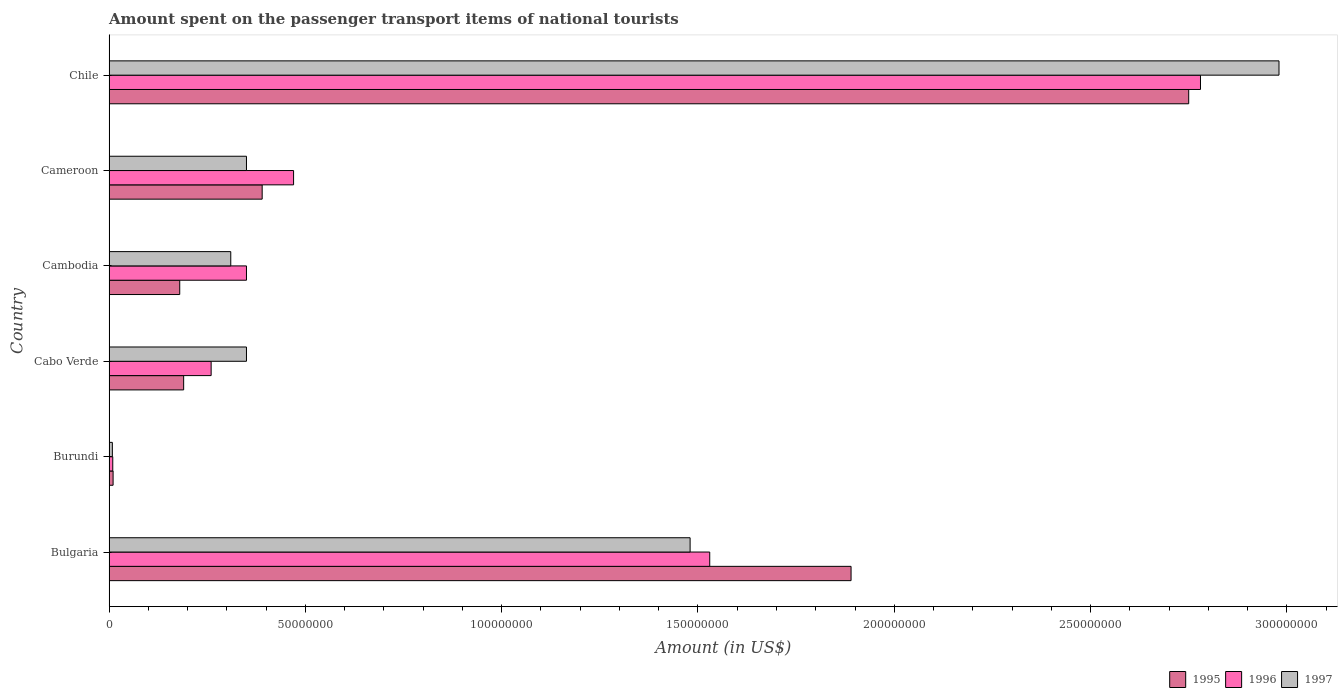How many different coloured bars are there?
Your response must be concise. 3. Are the number of bars on each tick of the Y-axis equal?
Offer a terse response. Yes. How many bars are there on the 4th tick from the bottom?
Make the answer very short. 3. What is the label of the 2nd group of bars from the top?
Your answer should be compact. Cameroon. In how many cases, is the number of bars for a given country not equal to the number of legend labels?
Offer a terse response. 0. What is the amount spent on the passenger transport items of national tourists in 1995 in Burundi?
Your response must be concise. 1.02e+06. Across all countries, what is the maximum amount spent on the passenger transport items of national tourists in 1996?
Make the answer very short. 2.78e+08. Across all countries, what is the minimum amount spent on the passenger transport items of national tourists in 1996?
Your answer should be very brief. 9.41e+05. In which country was the amount spent on the passenger transport items of national tourists in 1997 maximum?
Provide a succinct answer. Chile. In which country was the amount spent on the passenger transport items of national tourists in 1996 minimum?
Your response must be concise. Burundi. What is the total amount spent on the passenger transport items of national tourists in 1995 in the graph?
Make the answer very short. 5.41e+08. What is the difference between the amount spent on the passenger transport items of national tourists in 1996 in Bulgaria and that in Cambodia?
Your response must be concise. 1.18e+08. What is the difference between the amount spent on the passenger transport items of national tourists in 1997 in Chile and the amount spent on the passenger transport items of national tourists in 1996 in Cambodia?
Offer a very short reply. 2.63e+08. What is the average amount spent on the passenger transport items of national tourists in 1996 per country?
Ensure brevity in your answer.  9.00e+07. What is the difference between the amount spent on the passenger transport items of national tourists in 1995 and amount spent on the passenger transport items of national tourists in 1996 in Chile?
Offer a very short reply. -3.00e+06. What is the ratio of the amount spent on the passenger transport items of national tourists in 1997 in Burundi to that in Cameroon?
Provide a succinct answer. 0.02. What is the difference between the highest and the second highest amount spent on the passenger transport items of national tourists in 1997?
Your answer should be very brief. 1.50e+08. What is the difference between the highest and the lowest amount spent on the passenger transport items of national tourists in 1995?
Offer a very short reply. 2.74e+08. Is the sum of the amount spent on the passenger transport items of national tourists in 1996 in Bulgaria and Burundi greater than the maximum amount spent on the passenger transport items of national tourists in 1995 across all countries?
Your answer should be compact. No. What does the 1st bar from the top in Burundi represents?
Your answer should be compact. 1997. What does the 1st bar from the bottom in Cameroon represents?
Make the answer very short. 1995. What is the difference between two consecutive major ticks on the X-axis?
Provide a short and direct response. 5.00e+07. Does the graph contain any zero values?
Make the answer very short. No. How many legend labels are there?
Give a very brief answer. 3. What is the title of the graph?
Your response must be concise. Amount spent on the passenger transport items of national tourists. Does "1979" appear as one of the legend labels in the graph?
Ensure brevity in your answer.  No. What is the label or title of the X-axis?
Offer a terse response. Amount (in US$). What is the label or title of the Y-axis?
Offer a terse response. Country. What is the Amount (in US$) of 1995 in Bulgaria?
Your answer should be very brief. 1.89e+08. What is the Amount (in US$) in 1996 in Bulgaria?
Your answer should be compact. 1.53e+08. What is the Amount (in US$) in 1997 in Bulgaria?
Your response must be concise. 1.48e+08. What is the Amount (in US$) in 1995 in Burundi?
Make the answer very short. 1.02e+06. What is the Amount (in US$) of 1996 in Burundi?
Ensure brevity in your answer.  9.41e+05. What is the Amount (in US$) of 1997 in Burundi?
Give a very brief answer. 8.40e+05. What is the Amount (in US$) in 1995 in Cabo Verde?
Make the answer very short. 1.90e+07. What is the Amount (in US$) of 1996 in Cabo Verde?
Your answer should be compact. 2.60e+07. What is the Amount (in US$) in 1997 in Cabo Verde?
Provide a short and direct response. 3.50e+07. What is the Amount (in US$) in 1995 in Cambodia?
Offer a terse response. 1.80e+07. What is the Amount (in US$) in 1996 in Cambodia?
Give a very brief answer. 3.50e+07. What is the Amount (in US$) of 1997 in Cambodia?
Give a very brief answer. 3.10e+07. What is the Amount (in US$) in 1995 in Cameroon?
Provide a short and direct response. 3.90e+07. What is the Amount (in US$) of 1996 in Cameroon?
Make the answer very short. 4.70e+07. What is the Amount (in US$) of 1997 in Cameroon?
Keep it short and to the point. 3.50e+07. What is the Amount (in US$) in 1995 in Chile?
Provide a succinct answer. 2.75e+08. What is the Amount (in US$) in 1996 in Chile?
Provide a short and direct response. 2.78e+08. What is the Amount (in US$) of 1997 in Chile?
Your response must be concise. 2.98e+08. Across all countries, what is the maximum Amount (in US$) of 1995?
Your answer should be very brief. 2.75e+08. Across all countries, what is the maximum Amount (in US$) in 1996?
Your response must be concise. 2.78e+08. Across all countries, what is the maximum Amount (in US$) in 1997?
Keep it short and to the point. 2.98e+08. Across all countries, what is the minimum Amount (in US$) in 1995?
Your answer should be very brief. 1.02e+06. Across all countries, what is the minimum Amount (in US$) in 1996?
Keep it short and to the point. 9.41e+05. Across all countries, what is the minimum Amount (in US$) of 1997?
Your response must be concise. 8.40e+05. What is the total Amount (in US$) in 1995 in the graph?
Make the answer very short. 5.41e+08. What is the total Amount (in US$) of 1996 in the graph?
Your answer should be very brief. 5.40e+08. What is the total Amount (in US$) in 1997 in the graph?
Provide a succinct answer. 5.48e+08. What is the difference between the Amount (in US$) of 1995 in Bulgaria and that in Burundi?
Offer a terse response. 1.88e+08. What is the difference between the Amount (in US$) in 1996 in Bulgaria and that in Burundi?
Keep it short and to the point. 1.52e+08. What is the difference between the Amount (in US$) of 1997 in Bulgaria and that in Burundi?
Your answer should be compact. 1.47e+08. What is the difference between the Amount (in US$) of 1995 in Bulgaria and that in Cabo Verde?
Your answer should be very brief. 1.70e+08. What is the difference between the Amount (in US$) in 1996 in Bulgaria and that in Cabo Verde?
Provide a short and direct response. 1.27e+08. What is the difference between the Amount (in US$) in 1997 in Bulgaria and that in Cabo Verde?
Your answer should be compact. 1.13e+08. What is the difference between the Amount (in US$) of 1995 in Bulgaria and that in Cambodia?
Your answer should be compact. 1.71e+08. What is the difference between the Amount (in US$) in 1996 in Bulgaria and that in Cambodia?
Provide a short and direct response. 1.18e+08. What is the difference between the Amount (in US$) in 1997 in Bulgaria and that in Cambodia?
Make the answer very short. 1.17e+08. What is the difference between the Amount (in US$) of 1995 in Bulgaria and that in Cameroon?
Offer a terse response. 1.50e+08. What is the difference between the Amount (in US$) of 1996 in Bulgaria and that in Cameroon?
Keep it short and to the point. 1.06e+08. What is the difference between the Amount (in US$) of 1997 in Bulgaria and that in Cameroon?
Your answer should be compact. 1.13e+08. What is the difference between the Amount (in US$) in 1995 in Bulgaria and that in Chile?
Provide a short and direct response. -8.60e+07. What is the difference between the Amount (in US$) of 1996 in Bulgaria and that in Chile?
Ensure brevity in your answer.  -1.25e+08. What is the difference between the Amount (in US$) of 1997 in Bulgaria and that in Chile?
Your answer should be compact. -1.50e+08. What is the difference between the Amount (in US$) in 1995 in Burundi and that in Cabo Verde?
Your response must be concise. -1.80e+07. What is the difference between the Amount (in US$) in 1996 in Burundi and that in Cabo Verde?
Your answer should be compact. -2.51e+07. What is the difference between the Amount (in US$) of 1997 in Burundi and that in Cabo Verde?
Make the answer very short. -3.42e+07. What is the difference between the Amount (in US$) in 1995 in Burundi and that in Cambodia?
Provide a short and direct response. -1.70e+07. What is the difference between the Amount (in US$) in 1996 in Burundi and that in Cambodia?
Make the answer very short. -3.41e+07. What is the difference between the Amount (in US$) in 1997 in Burundi and that in Cambodia?
Give a very brief answer. -3.02e+07. What is the difference between the Amount (in US$) of 1995 in Burundi and that in Cameroon?
Provide a short and direct response. -3.80e+07. What is the difference between the Amount (in US$) of 1996 in Burundi and that in Cameroon?
Provide a short and direct response. -4.61e+07. What is the difference between the Amount (in US$) in 1997 in Burundi and that in Cameroon?
Make the answer very short. -3.42e+07. What is the difference between the Amount (in US$) of 1995 in Burundi and that in Chile?
Keep it short and to the point. -2.74e+08. What is the difference between the Amount (in US$) of 1996 in Burundi and that in Chile?
Offer a very short reply. -2.77e+08. What is the difference between the Amount (in US$) in 1997 in Burundi and that in Chile?
Provide a succinct answer. -2.97e+08. What is the difference between the Amount (in US$) of 1995 in Cabo Verde and that in Cambodia?
Ensure brevity in your answer.  1.00e+06. What is the difference between the Amount (in US$) of 1996 in Cabo Verde and that in Cambodia?
Provide a short and direct response. -9.00e+06. What is the difference between the Amount (in US$) in 1997 in Cabo Verde and that in Cambodia?
Your response must be concise. 4.00e+06. What is the difference between the Amount (in US$) of 1995 in Cabo Verde and that in Cameroon?
Offer a very short reply. -2.00e+07. What is the difference between the Amount (in US$) of 1996 in Cabo Verde and that in Cameroon?
Ensure brevity in your answer.  -2.10e+07. What is the difference between the Amount (in US$) in 1995 in Cabo Verde and that in Chile?
Your answer should be compact. -2.56e+08. What is the difference between the Amount (in US$) in 1996 in Cabo Verde and that in Chile?
Offer a terse response. -2.52e+08. What is the difference between the Amount (in US$) in 1997 in Cabo Verde and that in Chile?
Your answer should be very brief. -2.63e+08. What is the difference between the Amount (in US$) of 1995 in Cambodia and that in Cameroon?
Make the answer very short. -2.10e+07. What is the difference between the Amount (in US$) in 1996 in Cambodia and that in Cameroon?
Ensure brevity in your answer.  -1.20e+07. What is the difference between the Amount (in US$) in 1997 in Cambodia and that in Cameroon?
Give a very brief answer. -4.00e+06. What is the difference between the Amount (in US$) in 1995 in Cambodia and that in Chile?
Give a very brief answer. -2.57e+08. What is the difference between the Amount (in US$) in 1996 in Cambodia and that in Chile?
Your answer should be very brief. -2.43e+08. What is the difference between the Amount (in US$) in 1997 in Cambodia and that in Chile?
Offer a very short reply. -2.67e+08. What is the difference between the Amount (in US$) of 1995 in Cameroon and that in Chile?
Offer a very short reply. -2.36e+08. What is the difference between the Amount (in US$) of 1996 in Cameroon and that in Chile?
Provide a succinct answer. -2.31e+08. What is the difference between the Amount (in US$) of 1997 in Cameroon and that in Chile?
Offer a terse response. -2.63e+08. What is the difference between the Amount (in US$) of 1995 in Bulgaria and the Amount (in US$) of 1996 in Burundi?
Your answer should be compact. 1.88e+08. What is the difference between the Amount (in US$) of 1995 in Bulgaria and the Amount (in US$) of 1997 in Burundi?
Offer a very short reply. 1.88e+08. What is the difference between the Amount (in US$) in 1996 in Bulgaria and the Amount (in US$) in 1997 in Burundi?
Offer a very short reply. 1.52e+08. What is the difference between the Amount (in US$) in 1995 in Bulgaria and the Amount (in US$) in 1996 in Cabo Verde?
Your answer should be very brief. 1.63e+08. What is the difference between the Amount (in US$) in 1995 in Bulgaria and the Amount (in US$) in 1997 in Cabo Verde?
Give a very brief answer. 1.54e+08. What is the difference between the Amount (in US$) in 1996 in Bulgaria and the Amount (in US$) in 1997 in Cabo Verde?
Keep it short and to the point. 1.18e+08. What is the difference between the Amount (in US$) in 1995 in Bulgaria and the Amount (in US$) in 1996 in Cambodia?
Your answer should be compact. 1.54e+08. What is the difference between the Amount (in US$) in 1995 in Bulgaria and the Amount (in US$) in 1997 in Cambodia?
Give a very brief answer. 1.58e+08. What is the difference between the Amount (in US$) of 1996 in Bulgaria and the Amount (in US$) of 1997 in Cambodia?
Offer a terse response. 1.22e+08. What is the difference between the Amount (in US$) in 1995 in Bulgaria and the Amount (in US$) in 1996 in Cameroon?
Give a very brief answer. 1.42e+08. What is the difference between the Amount (in US$) of 1995 in Bulgaria and the Amount (in US$) of 1997 in Cameroon?
Give a very brief answer. 1.54e+08. What is the difference between the Amount (in US$) in 1996 in Bulgaria and the Amount (in US$) in 1997 in Cameroon?
Make the answer very short. 1.18e+08. What is the difference between the Amount (in US$) in 1995 in Bulgaria and the Amount (in US$) in 1996 in Chile?
Your answer should be compact. -8.90e+07. What is the difference between the Amount (in US$) of 1995 in Bulgaria and the Amount (in US$) of 1997 in Chile?
Ensure brevity in your answer.  -1.09e+08. What is the difference between the Amount (in US$) of 1996 in Bulgaria and the Amount (in US$) of 1997 in Chile?
Provide a short and direct response. -1.45e+08. What is the difference between the Amount (in US$) of 1995 in Burundi and the Amount (in US$) of 1996 in Cabo Verde?
Provide a succinct answer. -2.50e+07. What is the difference between the Amount (in US$) of 1995 in Burundi and the Amount (in US$) of 1997 in Cabo Verde?
Give a very brief answer. -3.40e+07. What is the difference between the Amount (in US$) of 1996 in Burundi and the Amount (in US$) of 1997 in Cabo Verde?
Ensure brevity in your answer.  -3.41e+07. What is the difference between the Amount (in US$) in 1995 in Burundi and the Amount (in US$) in 1996 in Cambodia?
Give a very brief answer. -3.40e+07. What is the difference between the Amount (in US$) of 1995 in Burundi and the Amount (in US$) of 1997 in Cambodia?
Make the answer very short. -3.00e+07. What is the difference between the Amount (in US$) of 1996 in Burundi and the Amount (in US$) of 1997 in Cambodia?
Your answer should be very brief. -3.01e+07. What is the difference between the Amount (in US$) of 1995 in Burundi and the Amount (in US$) of 1996 in Cameroon?
Provide a short and direct response. -4.60e+07. What is the difference between the Amount (in US$) in 1995 in Burundi and the Amount (in US$) in 1997 in Cameroon?
Make the answer very short. -3.40e+07. What is the difference between the Amount (in US$) of 1996 in Burundi and the Amount (in US$) of 1997 in Cameroon?
Ensure brevity in your answer.  -3.41e+07. What is the difference between the Amount (in US$) of 1995 in Burundi and the Amount (in US$) of 1996 in Chile?
Make the answer very short. -2.77e+08. What is the difference between the Amount (in US$) in 1995 in Burundi and the Amount (in US$) in 1997 in Chile?
Provide a short and direct response. -2.97e+08. What is the difference between the Amount (in US$) of 1996 in Burundi and the Amount (in US$) of 1997 in Chile?
Give a very brief answer. -2.97e+08. What is the difference between the Amount (in US$) in 1995 in Cabo Verde and the Amount (in US$) in 1996 in Cambodia?
Your response must be concise. -1.60e+07. What is the difference between the Amount (in US$) in 1995 in Cabo Verde and the Amount (in US$) in 1997 in Cambodia?
Your answer should be very brief. -1.20e+07. What is the difference between the Amount (in US$) in 1996 in Cabo Verde and the Amount (in US$) in 1997 in Cambodia?
Make the answer very short. -5.00e+06. What is the difference between the Amount (in US$) of 1995 in Cabo Verde and the Amount (in US$) of 1996 in Cameroon?
Make the answer very short. -2.80e+07. What is the difference between the Amount (in US$) in 1995 in Cabo Verde and the Amount (in US$) in 1997 in Cameroon?
Make the answer very short. -1.60e+07. What is the difference between the Amount (in US$) in 1996 in Cabo Verde and the Amount (in US$) in 1997 in Cameroon?
Provide a short and direct response. -9.00e+06. What is the difference between the Amount (in US$) of 1995 in Cabo Verde and the Amount (in US$) of 1996 in Chile?
Provide a short and direct response. -2.59e+08. What is the difference between the Amount (in US$) in 1995 in Cabo Verde and the Amount (in US$) in 1997 in Chile?
Your answer should be very brief. -2.79e+08. What is the difference between the Amount (in US$) of 1996 in Cabo Verde and the Amount (in US$) of 1997 in Chile?
Ensure brevity in your answer.  -2.72e+08. What is the difference between the Amount (in US$) of 1995 in Cambodia and the Amount (in US$) of 1996 in Cameroon?
Your answer should be very brief. -2.90e+07. What is the difference between the Amount (in US$) of 1995 in Cambodia and the Amount (in US$) of 1997 in Cameroon?
Give a very brief answer. -1.70e+07. What is the difference between the Amount (in US$) of 1995 in Cambodia and the Amount (in US$) of 1996 in Chile?
Give a very brief answer. -2.60e+08. What is the difference between the Amount (in US$) of 1995 in Cambodia and the Amount (in US$) of 1997 in Chile?
Provide a short and direct response. -2.80e+08. What is the difference between the Amount (in US$) in 1996 in Cambodia and the Amount (in US$) in 1997 in Chile?
Keep it short and to the point. -2.63e+08. What is the difference between the Amount (in US$) of 1995 in Cameroon and the Amount (in US$) of 1996 in Chile?
Provide a succinct answer. -2.39e+08. What is the difference between the Amount (in US$) in 1995 in Cameroon and the Amount (in US$) in 1997 in Chile?
Provide a succinct answer. -2.59e+08. What is the difference between the Amount (in US$) of 1996 in Cameroon and the Amount (in US$) of 1997 in Chile?
Your answer should be compact. -2.51e+08. What is the average Amount (in US$) of 1995 per country?
Provide a short and direct response. 9.02e+07. What is the average Amount (in US$) in 1996 per country?
Keep it short and to the point. 9.00e+07. What is the average Amount (in US$) of 1997 per country?
Provide a succinct answer. 9.13e+07. What is the difference between the Amount (in US$) of 1995 and Amount (in US$) of 1996 in Bulgaria?
Your answer should be very brief. 3.60e+07. What is the difference between the Amount (in US$) of 1995 and Amount (in US$) of 1997 in Bulgaria?
Offer a terse response. 4.10e+07. What is the difference between the Amount (in US$) in 1995 and Amount (in US$) in 1996 in Burundi?
Ensure brevity in your answer.  8.36e+04. What is the difference between the Amount (in US$) of 1995 and Amount (in US$) of 1997 in Burundi?
Offer a very short reply. 1.85e+05. What is the difference between the Amount (in US$) of 1996 and Amount (in US$) of 1997 in Burundi?
Give a very brief answer. 1.01e+05. What is the difference between the Amount (in US$) in 1995 and Amount (in US$) in 1996 in Cabo Verde?
Provide a short and direct response. -7.00e+06. What is the difference between the Amount (in US$) of 1995 and Amount (in US$) of 1997 in Cabo Verde?
Provide a succinct answer. -1.60e+07. What is the difference between the Amount (in US$) in 1996 and Amount (in US$) in 1997 in Cabo Verde?
Ensure brevity in your answer.  -9.00e+06. What is the difference between the Amount (in US$) in 1995 and Amount (in US$) in 1996 in Cambodia?
Make the answer very short. -1.70e+07. What is the difference between the Amount (in US$) in 1995 and Amount (in US$) in 1997 in Cambodia?
Your answer should be compact. -1.30e+07. What is the difference between the Amount (in US$) of 1996 and Amount (in US$) of 1997 in Cambodia?
Offer a very short reply. 4.00e+06. What is the difference between the Amount (in US$) in 1995 and Amount (in US$) in 1996 in Cameroon?
Provide a succinct answer. -8.00e+06. What is the difference between the Amount (in US$) of 1995 and Amount (in US$) of 1996 in Chile?
Offer a very short reply. -3.00e+06. What is the difference between the Amount (in US$) in 1995 and Amount (in US$) in 1997 in Chile?
Provide a short and direct response. -2.30e+07. What is the difference between the Amount (in US$) in 1996 and Amount (in US$) in 1997 in Chile?
Provide a short and direct response. -2.00e+07. What is the ratio of the Amount (in US$) of 1995 in Bulgaria to that in Burundi?
Provide a short and direct response. 184.39. What is the ratio of the Amount (in US$) of 1996 in Bulgaria to that in Burundi?
Make the answer very short. 162.53. What is the ratio of the Amount (in US$) in 1997 in Bulgaria to that in Burundi?
Make the answer very short. 176.18. What is the ratio of the Amount (in US$) in 1995 in Bulgaria to that in Cabo Verde?
Give a very brief answer. 9.95. What is the ratio of the Amount (in US$) in 1996 in Bulgaria to that in Cabo Verde?
Your answer should be compact. 5.88. What is the ratio of the Amount (in US$) in 1997 in Bulgaria to that in Cabo Verde?
Offer a terse response. 4.23. What is the ratio of the Amount (in US$) of 1996 in Bulgaria to that in Cambodia?
Keep it short and to the point. 4.37. What is the ratio of the Amount (in US$) of 1997 in Bulgaria to that in Cambodia?
Offer a very short reply. 4.77. What is the ratio of the Amount (in US$) of 1995 in Bulgaria to that in Cameroon?
Your response must be concise. 4.85. What is the ratio of the Amount (in US$) of 1996 in Bulgaria to that in Cameroon?
Provide a short and direct response. 3.26. What is the ratio of the Amount (in US$) in 1997 in Bulgaria to that in Cameroon?
Provide a short and direct response. 4.23. What is the ratio of the Amount (in US$) in 1995 in Bulgaria to that in Chile?
Offer a very short reply. 0.69. What is the ratio of the Amount (in US$) of 1996 in Bulgaria to that in Chile?
Ensure brevity in your answer.  0.55. What is the ratio of the Amount (in US$) in 1997 in Bulgaria to that in Chile?
Offer a very short reply. 0.5. What is the ratio of the Amount (in US$) in 1995 in Burundi to that in Cabo Verde?
Keep it short and to the point. 0.05. What is the ratio of the Amount (in US$) of 1996 in Burundi to that in Cabo Verde?
Offer a very short reply. 0.04. What is the ratio of the Amount (in US$) in 1997 in Burundi to that in Cabo Verde?
Provide a succinct answer. 0.02. What is the ratio of the Amount (in US$) of 1995 in Burundi to that in Cambodia?
Your answer should be compact. 0.06. What is the ratio of the Amount (in US$) of 1996 in Burundi to that in Cambodia?
Provide a short and direct response. 0.03. What is the ratio of the Amount (in US$) of 1997 in Burundi to that in Cambodia?
Your answer should be compact. 0.03. What is the ratio of the Amount (in US$) in 1995 in Burundi to that in Cameroon?
Give a very brief answer. 0.03. What is the ratio of the Amount (in US$) in 1997 in Burundi to that in Cameroon?
Provide a short and direct response. 0.02. What is the ratio of the Amount (in US$) in 1995 in Burundi to that in Chile?
Offer a very short reply. 0. What is the ratio of the Amount (in US$) in 1996 in Burundi to that in Chile?
Offer a very short reply. 0. What is the ratio of the Amount (in US$) in 1997 in Burundi to that in Chile?
Give a very brief answer. 0. What is the ratio of the Amount (in US$) of 1995 in Cabo Verde to that in Cambodia?
Ensure brevity in your answer.  1.06. What is the ratio of the Amount (in US$) of 1996 in Cabo Verde to that in Cambodia?
Offer a very short reply. 0.74. What is the ratio of the Amount (in US$) in 1997 in Cabo Verde to that in Cambodia?
Offer a terse response. 1.13. What is the ratio of the Amount (in US$) in 1995 in Cabo Verde to that in Cameroon?
Offer a terse response. 0.49. What is the ratio of the Amount (in US$) of 1996 in Cabo Verde to that in Cameroon?
Offer a terse response. 0.55. What is the ratio of the Amount (in US$) of 1995 in Cabo Verde to that in Chile?
Provide a short and direct response. 0.07. What is the ratio of the Amount (in US$) in 1996 in Cabo Verde to that in Chile?
Offer a very short reply. 0.09. What is the ratio of the Amount (in US$) in 1997 in Cabo Verde to that in Chile?
Ensure brevity in your answer.  0.12. What is the ratio of the Amount (in US$) in 1995 in Cambodia to that in Cameroon?
Keep it short and to the point. 0.46. What is the ratio of the Amount (in US$) of 1996 in Cambodia to that in Cameroon?
Your answer should be very brief. 0.74. What is the ratio of the Amount (in US$) of 1997 in Cambodia to that in Cameroon?
Your answer should be compact. 0.89. What is the ratio of the Amount (in US$) of 1995 in Cambodia to that in Chile?
Your answer should be compact. 0.07. What is the ratio of the Amount (in US$) of 1996 in Cambodia to that in Chile?
Provide a short and direct response. 0.13. What is the ratio of the Amount (in US$) in 1997 in Cambodia to that in Chile?
Provide a short and direct response. 0.1. What is the ratio of the Amount (in US$) in 1995 in Cameroon to that in Chile?
Give a very brief answer. 0.14. What is the ratio of the Amount (in US$) in 1996 in Cameroon to that in Chile?
Your answer should be compact. 0.17. What is the ratio of the Amount (in US$) of 1997 in Cameroon to that in Chile?
Your answer should be compact. 0.12. What is the difference between the highest and the second highest Amount (in US$) of 1995?
Offer a terse response. 8.60e+07. What is the difference between the highest and the second highest Amount (in US$) of 1996?
Your answer should be compact. 1.25e+08. What is the difference between the highest and the second highest Amount (in US$) in 1997?
Provide a short and direct response. 1.50e+08. What is the difference between the highest and the lowest Amount (in US$) in 1995?
Your response must be concise. 2.74e+08. What is the difference between the highest and the lowest Amount (in US$) in 1996?
Provide a succinct answer. 2.77e+08. What is the difference between the highest and the lowest Amount (in US$) in 1997?
Your response must be concise. 2.97e+08. 